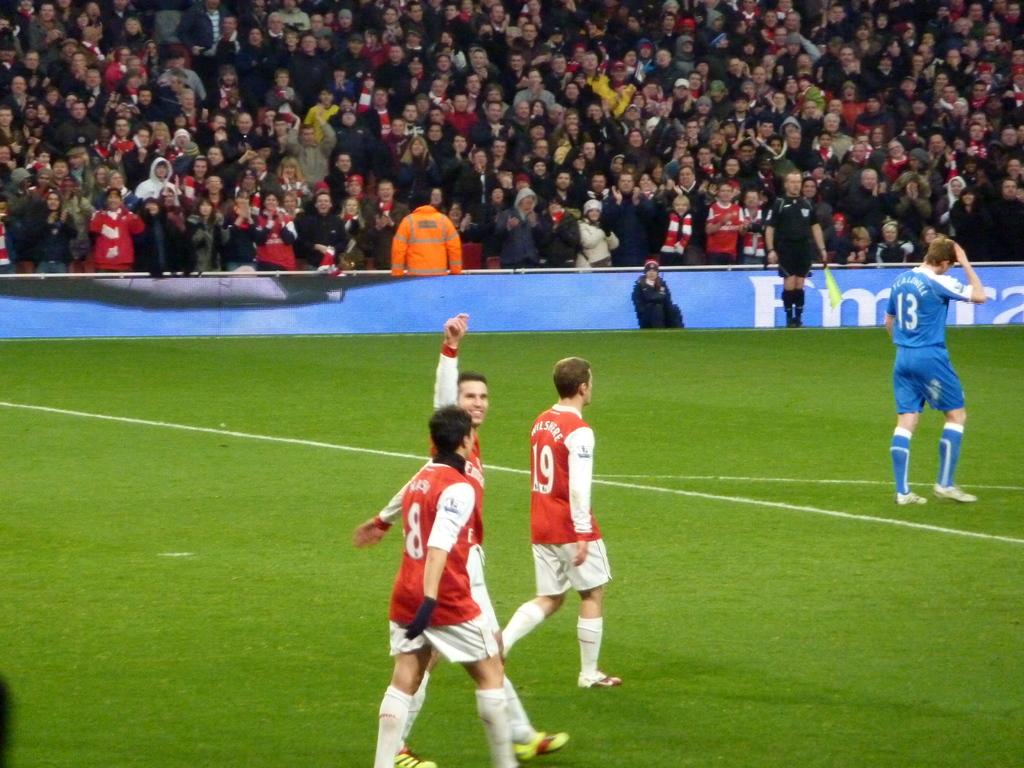<image>
Provide a brief description of the given image. soccer game where number 13 in blue looks a little distressed while the players  in red seem cheerful 